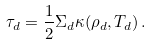<formula> <loc_0><loc_0><loc_500><loc_500>\tau _ { d } = \frac { 1 } { 2 } \Sigma _ { d } \kappa ( \rho _ { d } , T _ { d } ) \, .</formula> 